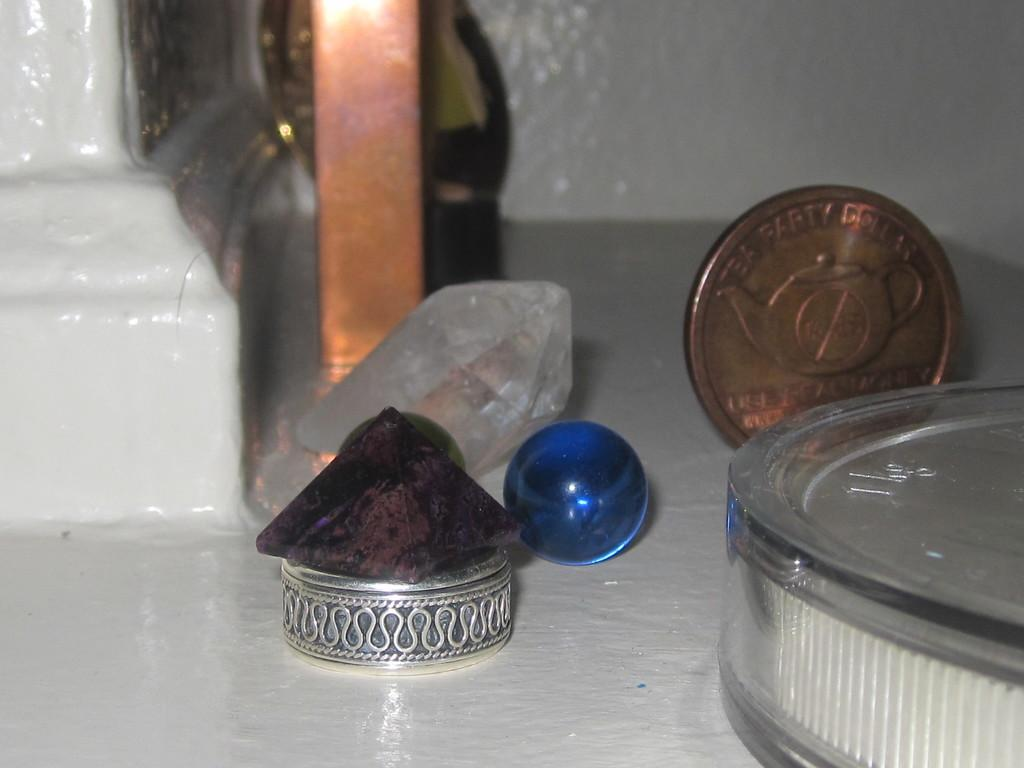<image>
Summarize the visual content of the image. A bronze coin saying Tea Party sits on a table wiht a marble and some precious stones. 